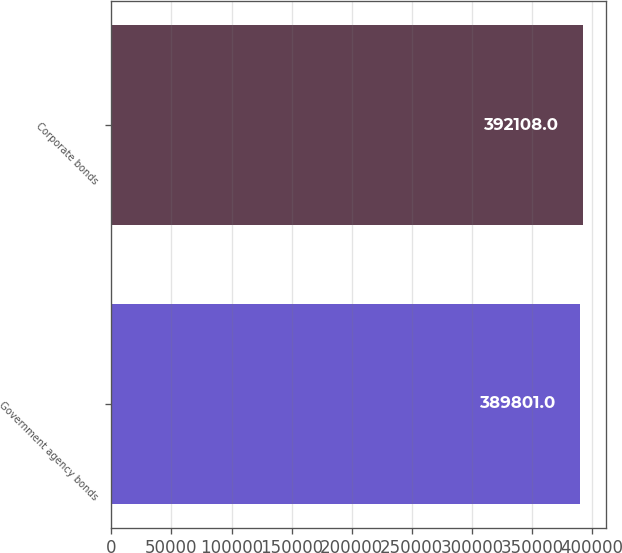Convert chart to OTSL. <chart><loc_0><loc_0><loc_500><loc_500><bar_chart><fcel>Government agency bonds<fcel>Corporate bonds<nl><fcel>389801<fcel>392108<nl></chart> 